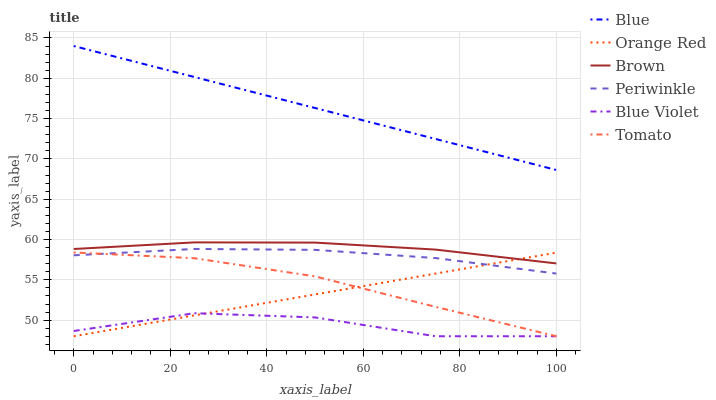Does Brown have the minimum area under the curve?
Answer yes or no. No. Does Brown have the maximum area under the curve?
Answer yes or no. No. Is Brown the smoothest?
Answer yes or no. No. Is Brown the roughest?
Answer yes or no. No. Does Brown have the lowest value?
Answer yes or no. No. Does Brown have the highest value?
Answer yes or no. No. Is Brown less than Blue?
Answer yes or no. Yes. Is Blue greater than Periwinkle?
Answer yes or no. Yes. Does Brown intersect Blue?
Answer yes or no. No. 